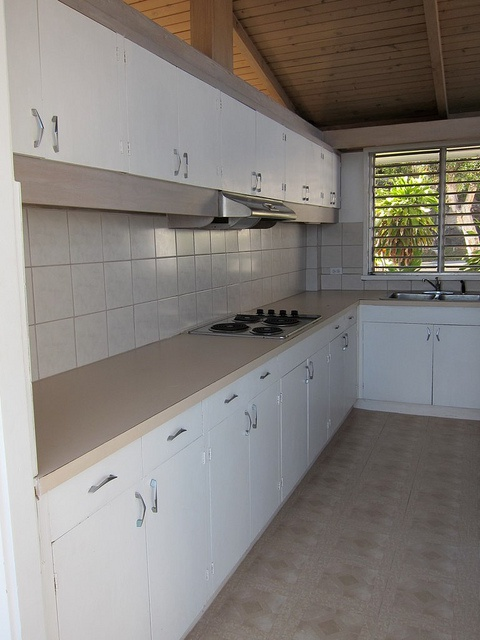Describe the objects in this image and their specific colors. I can see oven in lightgray, black, and gray tones and sink in lightgray, gray, black, and darkgray tones in this image. 